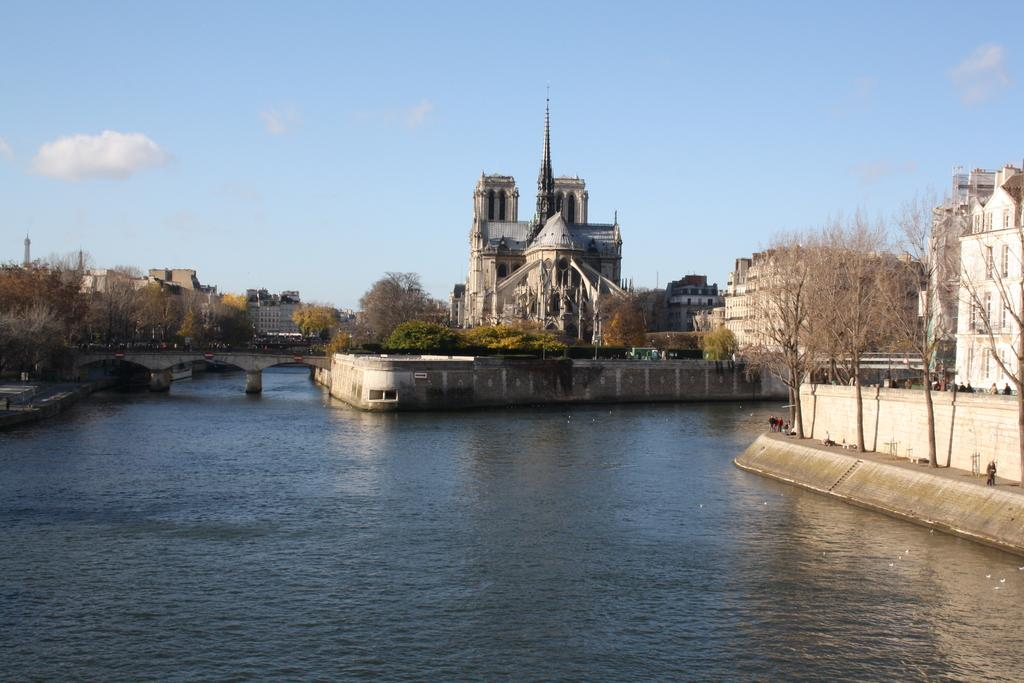What is visible at the bottom of the image? There is water visible at the bottom of the image. What can be seen in the background of the image? There are buildings, persons, trees, a bridge, and clouds in the sky in the background of the image. How many times does the person in the image fold their arms? There is no person folding their arms in the image; the person is simply present in the background. 